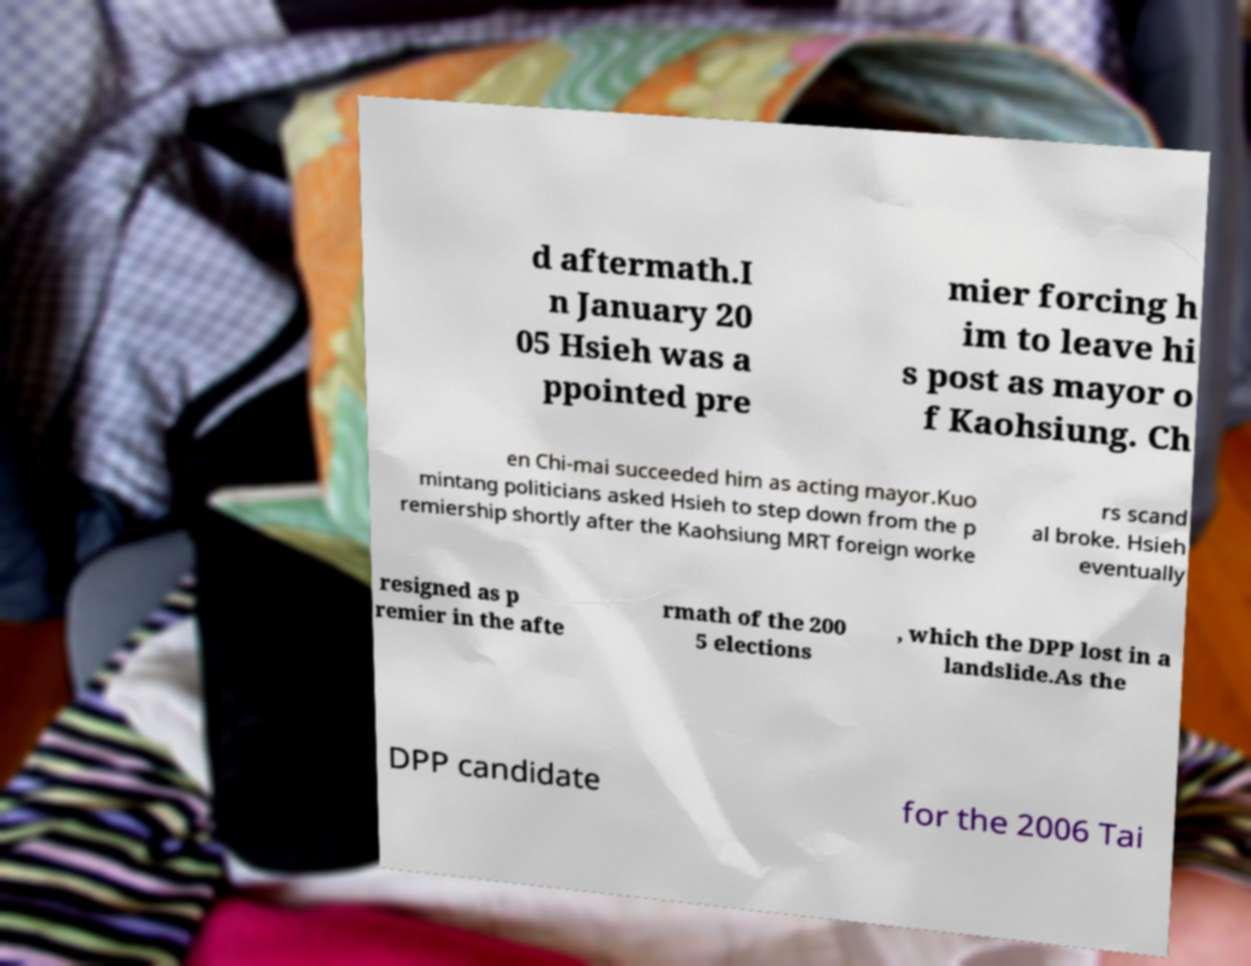For documentation purposes, I need the text within this image transcribed. Could you provide that? d aftermath.I n January 20 05 Hsieh was a ppointed pre mier forcing h im to leave hi s post as mayor o f Kaohsiung. Ch en Chi-mai succeeded him as acting mayor.Kuo mintang politicians asked Hsieh to step down from the p remiership shortly after the Kaohsiung MRT foreign worke rs scand al broke. Hsieh eventually resigned as p remier in the afte rmath of the 200 5 elections , which the DPP lost in a landslide.As the DPP candidate for the 2006 Tai 